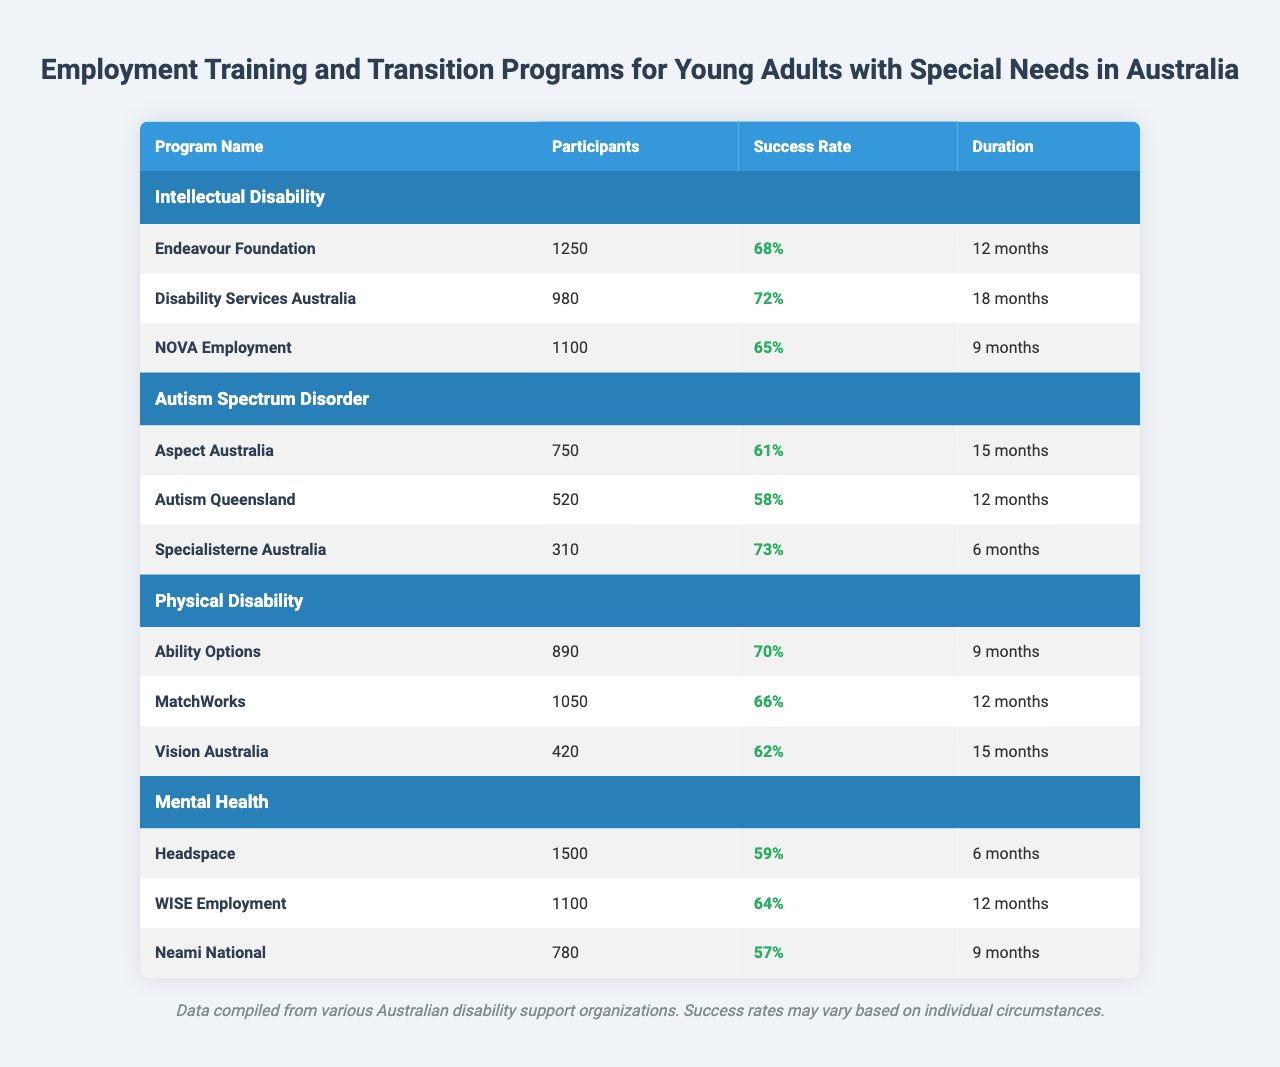What is the success rate of the Endeavour Foundation program? The table lists the Endeavour Foundation program under Intellectual Disability, and its success rate is indicated as 68%.
Answer: 68% How many participants are involved in the Autism Queensland program? The Autism Queensland program is listed in the Autism Spectrum Disorder section, with a total of 520 participants.
Answer: 520 Which program for Mental Health has the highest success rate? By examining the success rates in the Mental Health section, Headspace has a success rate of 59%, WISE Employment has 64%, and Neami National has 57%. WISE Employment has the highest success rate at 64%.
Answer: WISE Employment What is the average success rate for programs under Physical Disability? The success rates for Physical Disability programs are 70%, 66%, and 62%. Their sum is 70 + 66 + 62 = 198, and dividing this sum by the number of programs (3) gives an average of 198/3 = 66%.
Answer: 66% How many more participants are there in the Headspace program compared to the Specialisterne Australia program? The Headspace program has 1500 participants, while Specialisterne Australia has 310 participants. The difference is calculated by subtracting 310 from 1500, which equals 1190.
Answer: 1190 Are there more participants in the Disability Services Australia program than in the Ability Options program? The Disability Services Australia program has 980 participants, while the Ability Options program has 890 participants. Since 980 is greater than 890, the answer is yes.
Answer: Yes Which program has the longest duration among all listed? To find the program with the longest duration, we look at each program’s duration. Endeavour Foundation has 12 months, Disability Services Australia has 18 months, NOVA Employment has 9 months, and so forth. Disability Services Australia has the longest duration of 18 months.
Answer: Disability Services Australia What is the total number of participants across all programs for Autism Spectrum Disorder? The participants in the Autism Spectrum Disorder programs are 750 (Aspect Australia) + 520 (Autism Queensland) + 310 (Specialisterne Australia), totaling 750 + 520 + 310 = 1580 participants.
Answer: 1580 Which disability type has the highest overall participant count? Summing the participants for each disability type reveals: Intellectual Disability (1250 + 980 + 1100 = 3330), Autism Spectrum Disorder (750 + 520 + 310 = 1580), Physical Disability (890 + 1050 + 420 = 2360), and Mental Health (1500 + 1100 + 780 = 3380). Intellectual Disability has the highest total at 3330.
Answer: Intellectual Disability Is there any program for Autism Spectrum Disorder with a success rate above 70%? The success rates for the Autism Spectrum Disorder programs are 61%, 58%, and 73%. Since 73% (Specialisterne Australia) is above 70%, the answer is yes.
Answer: Yes 